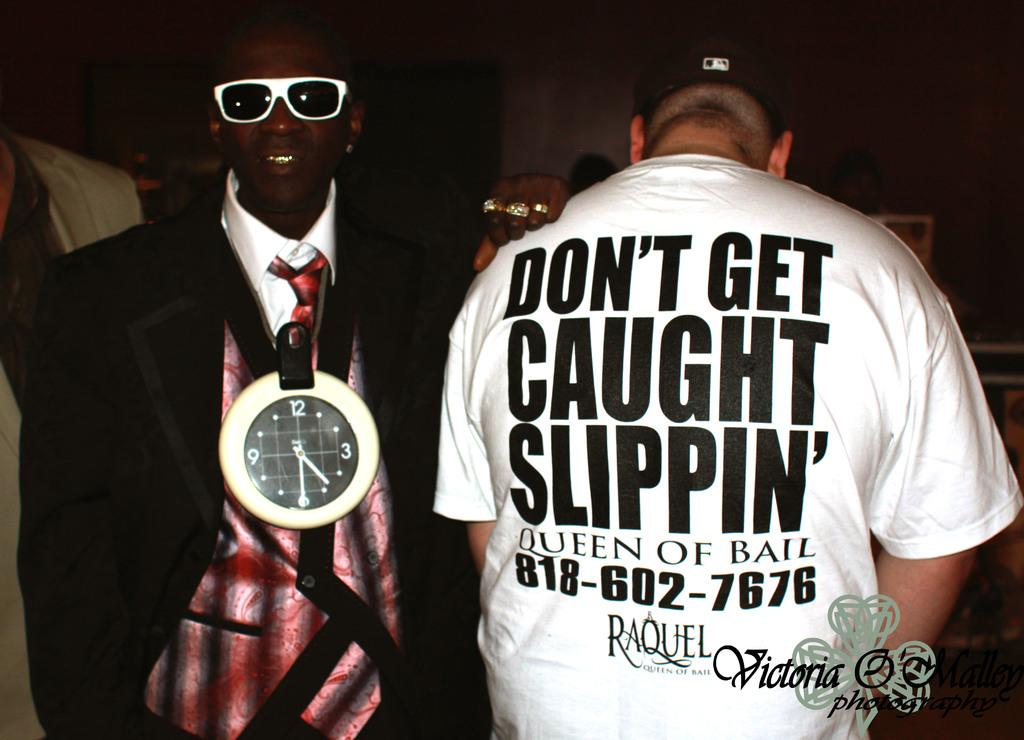<image>
Create a compact narrative representing the image presented. Person wearing a shirt which tells people to not get caught slipping. 